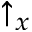<formula> <loc_0><loc_0><loc_500><loc_500>\uparrow _ { x }</formula> 